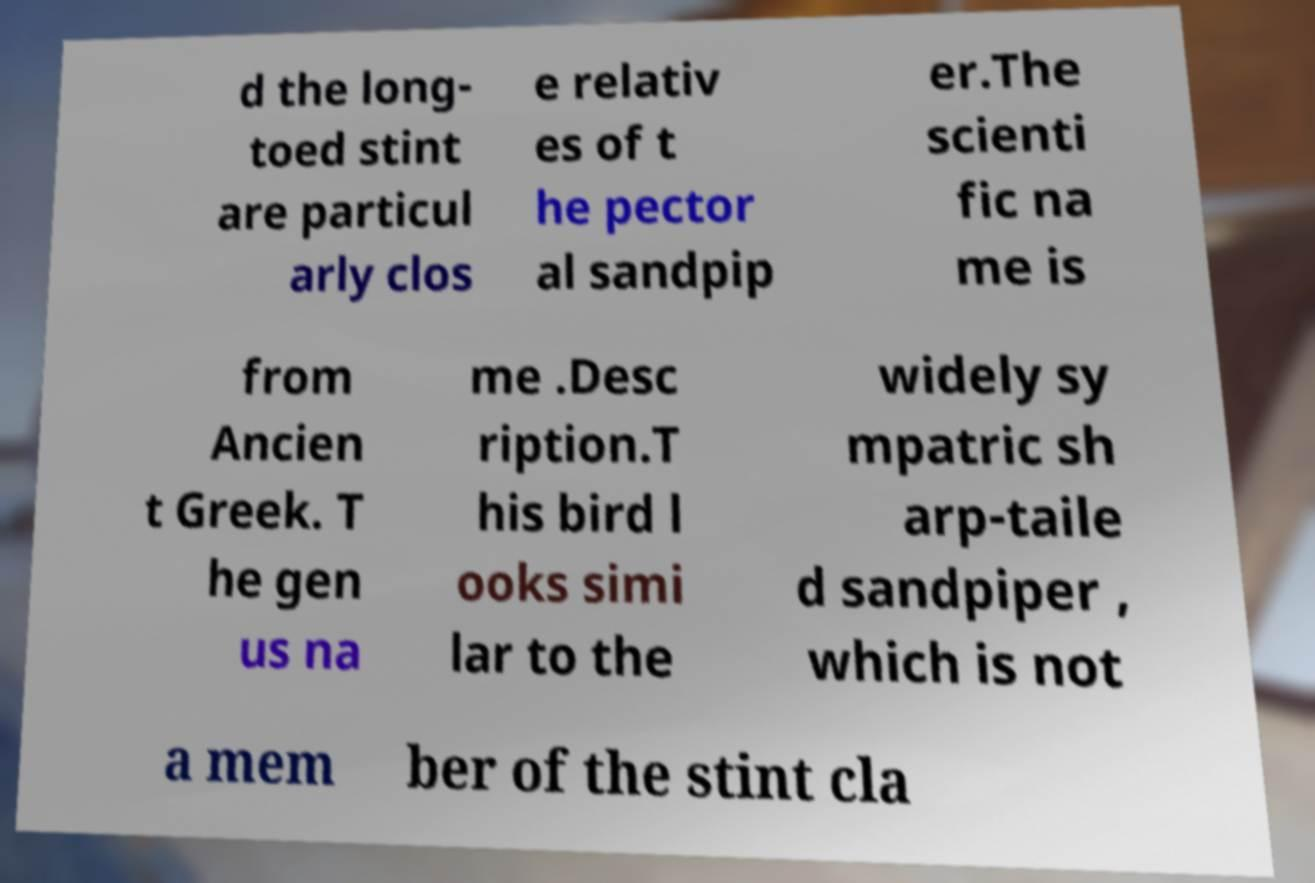Can you read and provide the text displayed in the image?This photo seems to have some interesting text. Can you extract and type it out for me? d the long- toed stint are particul arly clos e relativ es of t he pector al sandpip er.The scienti fic na me is from Ancien t Greek. T he gen us na me .Desc ription.T his bird l ooks simi lar to the widely sy mpatric sh arp-taile d sandpiper , which is not a mem ber of the stint cla 